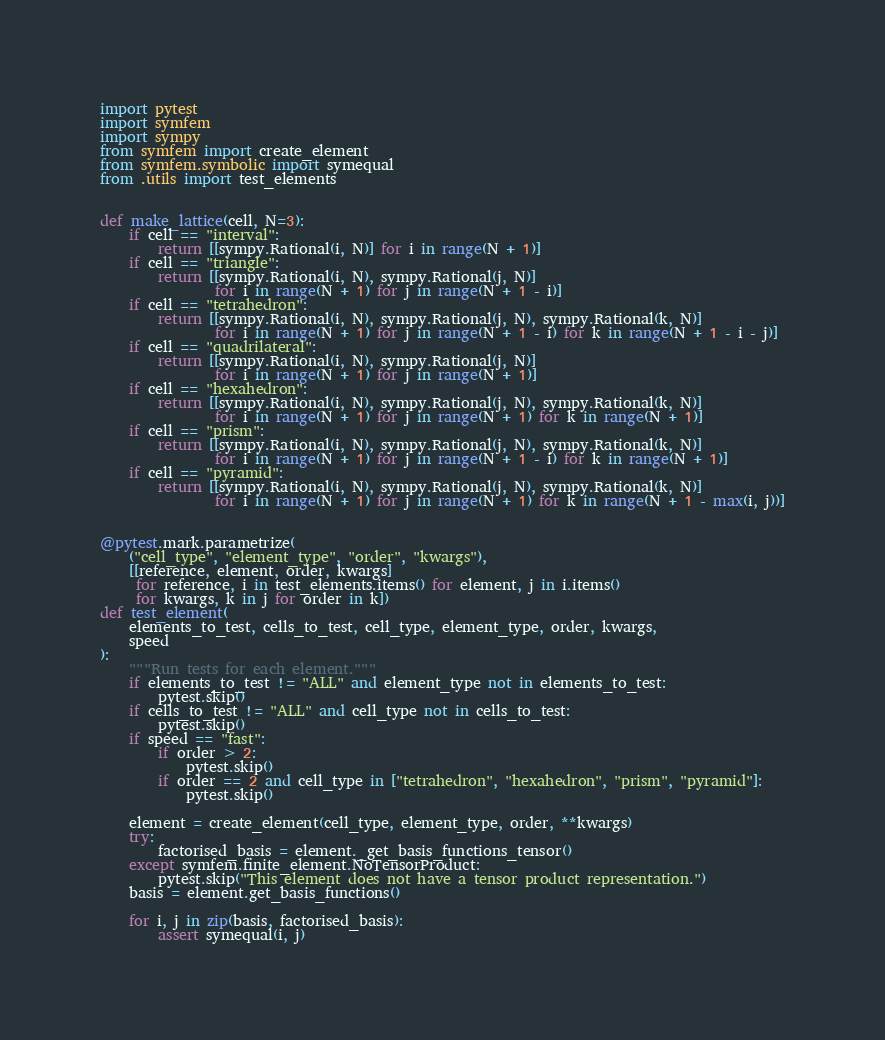<code> <loc_0><loc_0><loc_500><loc_500><_Python_>import pytest
import symfem
import sympy
from symfem import create_element
from symfem.symbolic import symequal
from .utils import test_elements


def make_lattice(cell, N=3):
    if cell == "interval":
        return [[sympy.Rational(i, N)] for i in range(N + 1)]
    if cell == "triangle":
        return [[sympy.Rational(i, N), sympy.Rational(j, N)]
                for i in range(N + 1) for j in range(N + 1 - i)]
    if cell == "tetrahedron":
        return [[sympy.Rational(i, N), sympy.Rational(j, N), sympy.Rational(k, N)]
                for i in range(N + 1) for j in range(N + 1 - i) for k in range(N + 1 - i - j)]
    if cell == "quadrilateral":
        return [[sympy.Rational(i, N), sympy.Rational(j, N)]
                for i in range(N + 1) for j in range(N + 1)]
    if cell == "hexahedron":
        return [[sympy.Rational(i, N), sympy.Rational(j, N), sympy.Rational(k, N)]
                for i in range(N + 1) for j in range(N + 1) for k in range(N + 1)]
    if cell == "prism":
        return [[sympy.Rational(i, N), sympy.Rational(j, N), sympy.Rational(k, N)]
                for i in range(N + 1) for j in range(N + 1 - i) for k in range(N + 1)]
    if cell == "pyramid":
        return [[sympy.Rational(i, N), sympy.Rational(j, N), sympy.Rational(k, N)]
                for i in range(N + 1) for j in range(N + 1) for k in range(N + 1 - max(i, j))]


@pytest.mark.parametrize(
    ("cell_type", "element_type", "order", "kwargs"),
    [[reference, element, order, kwargs]
     for reference, i in test_elements.items() for element, j in i.items()
     for kwargs, k in j for order in k])
def test_element(
    elements_to_test, cells_to_test, cell_type, element_type, order, kwargs,
    speed
):
    """Run tests for each element."""
    if elements_to_test != "ALL" and element_type not in elements_to_test:
        pytest.skip()
    if cells_to_test != "ALL" and cell_type not in cells_to_test:
        pytest.skip()
    if speed == "fast":
        if order > 2:
            pytest.skip()
        if order == 2 and cell_type in ["tetrahedron", "hexahedron", "prism", "pyramid"]:
            pytest.skip()

    element = create_element(cell_type, element_type, order, **kwargs)
    try:
        factorised_basis = element._get_basis_functions_tensor()
    except symfem.finite_element.NoTensorProduct:
        pytest.skip("This element does not have a tensor product representation.")
    basis = element.get_basis_functions()

    for i, j in zip(basis, factorised_basis):
        assert symequal(i, j)
</code> 